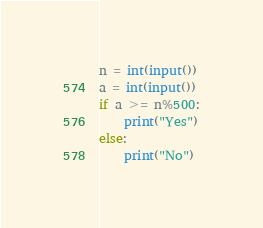<code> <loc_0><loc_0><loc_500><loc_500><_Python_>n = int(input())
a = int(input())
if a >= n%500:
	print("Yes")
else:
	print("No")</code> 